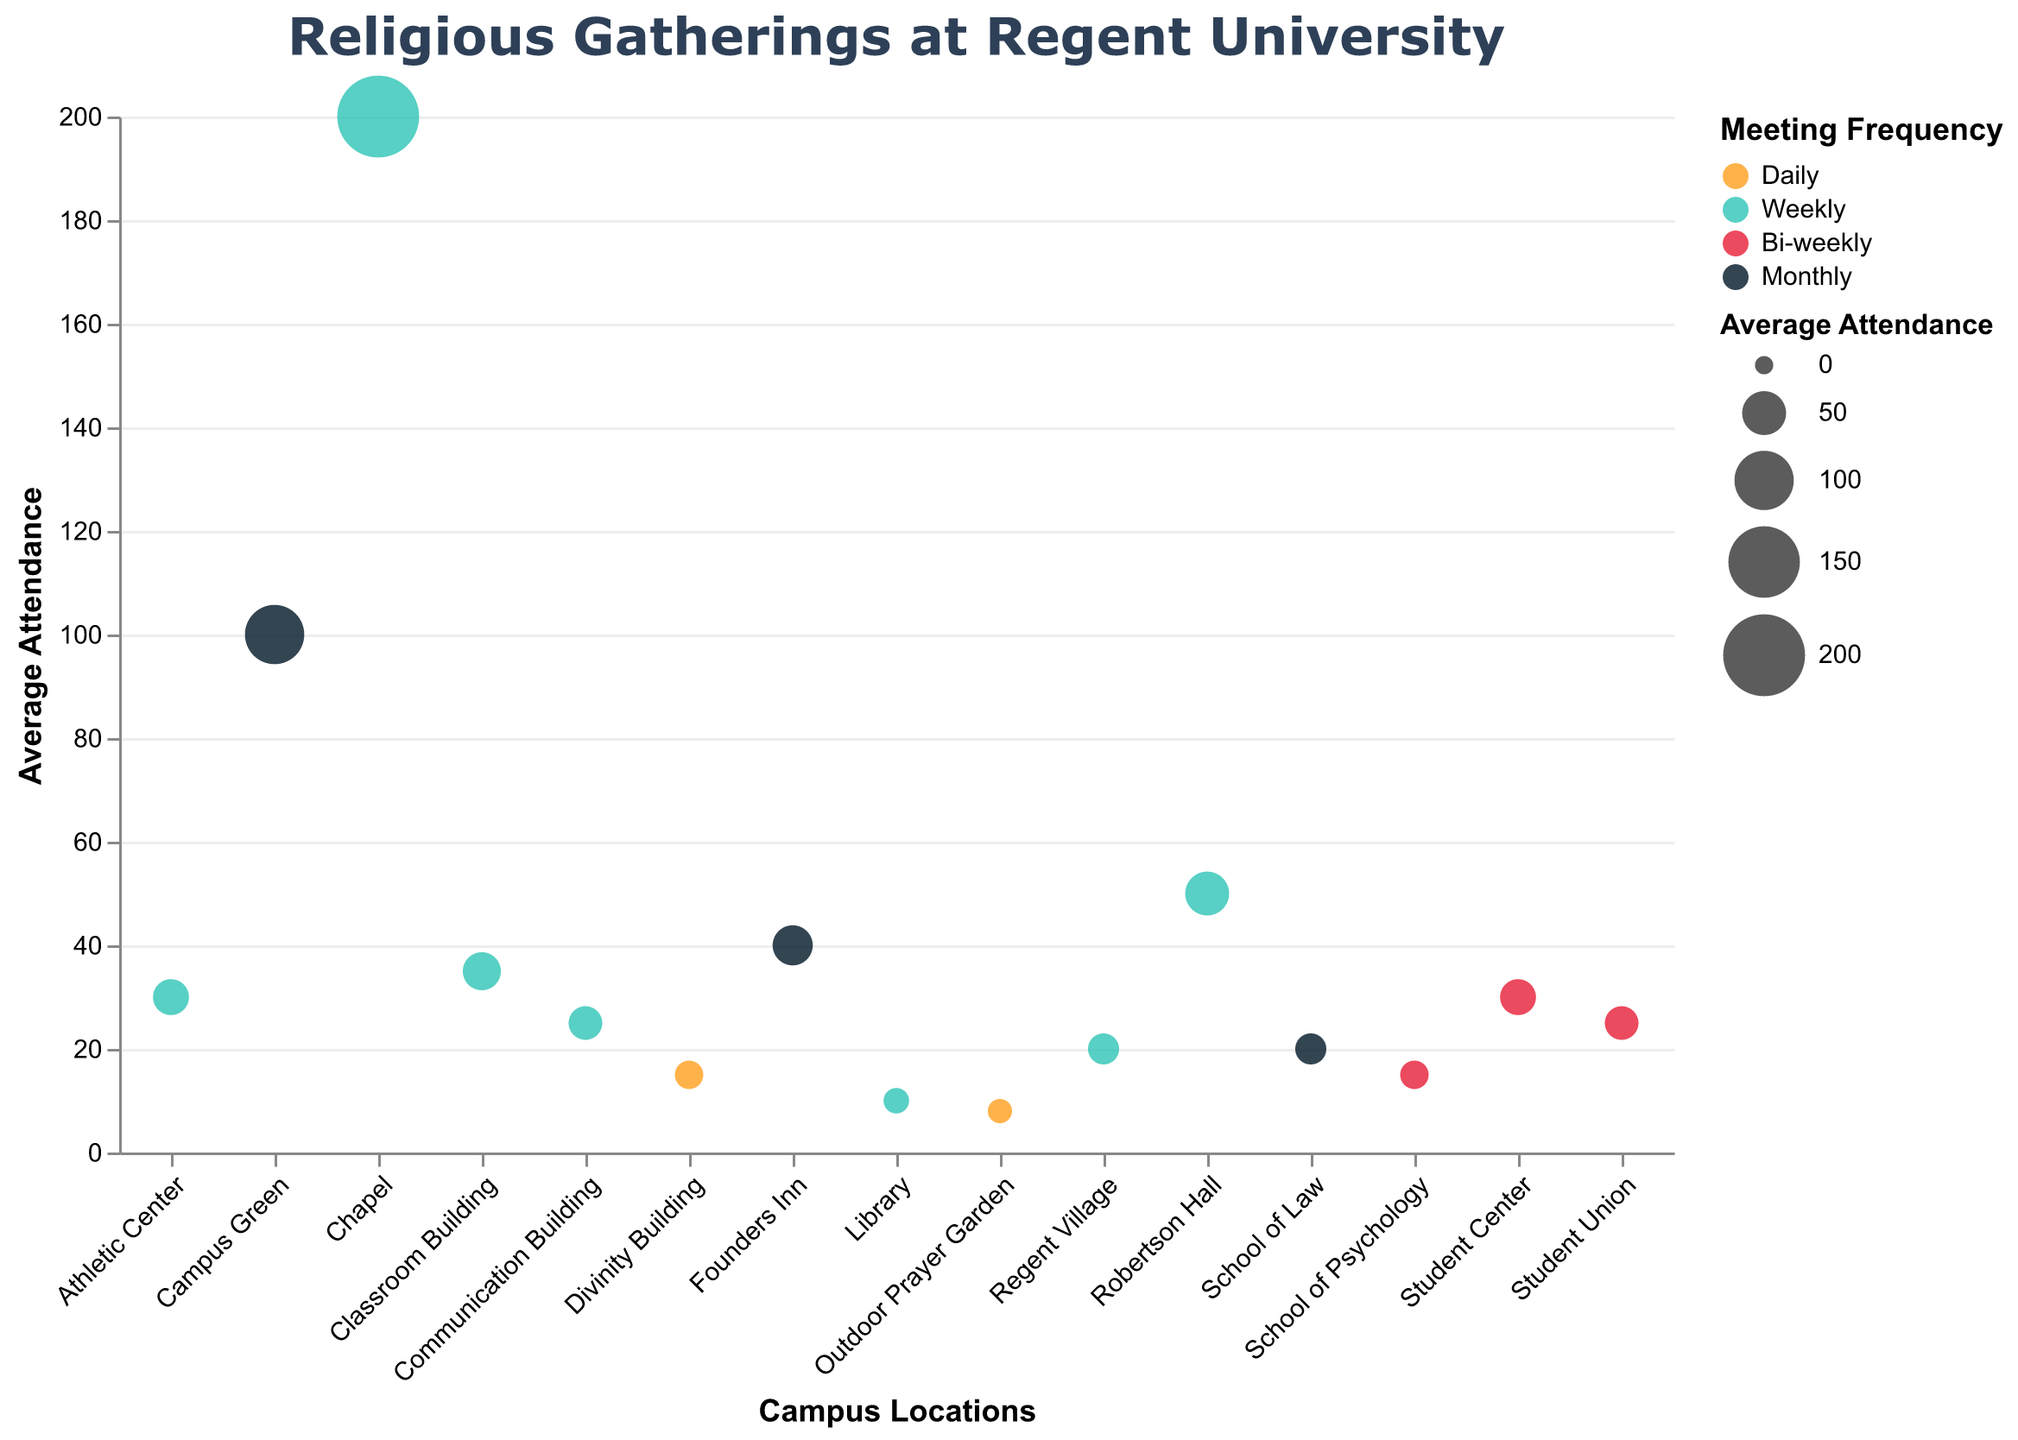What's the title of the plot? The title is displayed at the top of the plot and describes the overall content of the figure.
Answer: Religious Gatherings at Regent University Which location hosts the event with the highest average attendance? Look for the data point with the largest size circle and verify the corresponding location from the tooltip.
Answer: Chapel How many locations host daily events? Identify circles with the color corresponding to "Daily" from the legend and count them.
Answer: 2 What is the total average attendance for all weekly events? Sum the average attendance values for all circles colored as "Weekly". Weekly events: Chapel (200), Library (10), Robertson Hall (50), Communication Building (25), Classroom Building (35), Regent Village (20), Athletic Center (30). Total = 200 + 10 + 50 + 25 + 35 + 20 + 30 = 370
Answer: 370 Which group has a higher average attendance: the International Student Ministry or the Family Prayer Group? Compare Average Attendance of International Student Ministry (Classroom Building) with Family Prayer Group (Regent Village) based on their tooltip data.
Answer: International Student Ministry Are there any monthly events with average attendance greater than 50? Check the tooltip data for all circles colored as "Monthly" and identify any with Average Attendance above 50.
Answer: No What’s the difference in average attendance between Worship Service and Gospel Choir Practice? Subtract average attendance of Gospel Choir Practice (25) from Worship Service (200). Difference = 200 - 25 = 175
Answer: 175 Which location hosts the most diverse types of religious gatherings? Identify the location with the highest variety of different group types, checking the Group Type in the tooltips. Multiple locations have distinct group types, ensuring a broad range is considered. Look for the primary location with colors representing various frequencies.
Answer: Student Center (if it appears most diverse by tooltip) or specific by Group Type count Which event occurs bi-weekly in the Student Union? Identify the circle representing "Bi-weekly" that is located at the "Student Union", by referencing the tooltip.
Answer: Catholic Student Association 